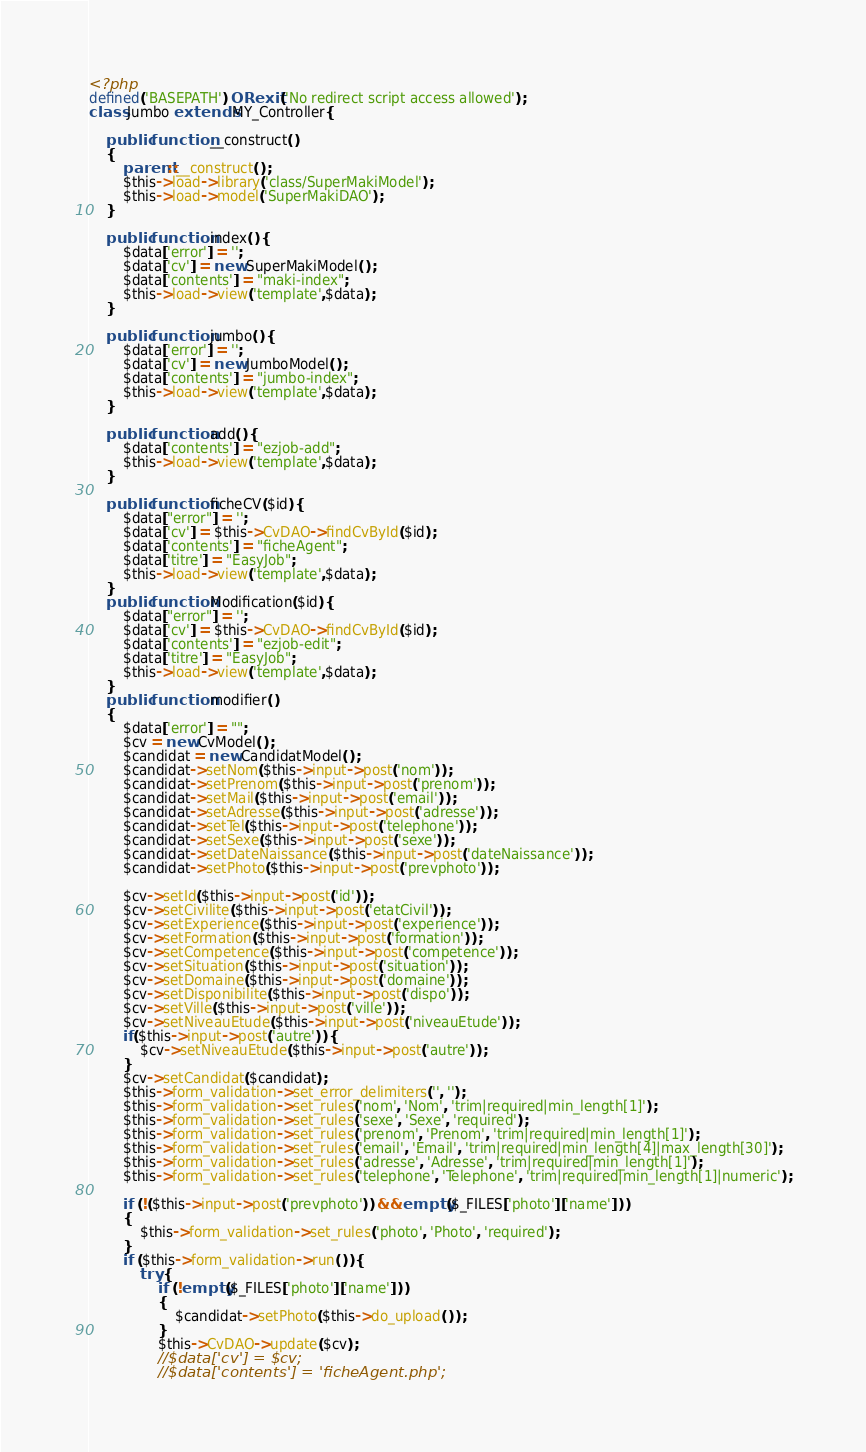<code> <loc_0><loc_0><loc_500><loc_500><_PHP_><?php
defined('BASEPATH') OR exit('No redirect script access allowed');
class Jumbo extends MY_Controller{

    public function __construct()
    {
        parent::__construct();
        $this->load->library('class/SuperMakiModel');
        $this->load->model('SuperMakiDAO');
    }

    public function index(){
        $data['error'] = '';
        $data['cv'] = new SuperMakiModel();
        $data['contents'] = "maki-index";
        $this->load->view('template',$data);
    }

    public function jumbo(){
        $data['error'] = '';
        $data['cv'] = new JumboModel();
        $data['contents'] = "jumbo-index";
        $this->load->view('template',$data);
    }

    public function add(){
        $data['contents'] = "ezjob-add";
        $this->load->view('template',$data);
    }

    public function ficheCV($id){
        $data["error"] = '';
        $data['cv'] = $this->CvDAO->findCvById($id);
        $data['contents'] = "ficheAgent";
        $data['titre'] = "EasyJob";
        $this->load->view('template',$data);
    }
    public function Modification($id){
        $data["error"] = '';
        $data['cv'] = $this->CvDAO->findCvById($id);
        $data['contents'] = "ezjob-edit";
        $data['titre'] = "EasyJob";
        $this->load->view('template',$data);
    }
    public function modifier()
    {
        $data['error'] = "";
        $cv = new CvModel();
        $candidat = new CandidatModel();
        $candidat->setNom($this->input->post('nom'));
        $candidat->setPrenom($this->input->post('prenom'));
        $candidat->setMail($this->input->post('email'));
        $candidat->setAdresse($this->input->post('adresse'));
        $candidat->setTel($this->input->post('telephone'));
        $candidat->setSexe($this->input->post('sexe'));
        $candidat->setDateNaissance($this->input->post('dateNaissance'));
        $candidat->setPhoto($this->input->post('prevphoto'));

        $cv->setId($this->input->post('id'));
        $cv->setCivilite($this->input->post('etatCivil'));
        $cv->setExperience($this->input->post('experience'));
        $cv->setFormation($this->input->post('formation'));
        $cv->setCompetence($this->input->post('competence'));
        $cv->setSituation($this->input->post('situation'));
        $cv->setDomaine($this->input->post('domaine'));
        $cv->setDisponibilite($this->input->post('dispo'));
        $cv->setVille($this->input->post('ville'));
        $cv->setNiveauEtude($this->input->post('niveauEtude'));
        if($this->input->post('autre')){
            $cv->setNiveauEtude($this->input->post('autre'));
        }
        $cv->setCandidat($candidat);
        $this->form_validation->set_error_delimiters('', '');
        $this->form_validation->set_rules('nom', 'Nom', 'trim|required|min_length[1]');
        $this->form_validation->set_rules('sexe', 'Sexe', 'required');
        $this->form_validation->set_rules('prenom', 'Prenom', 'trim|required|min_length[1]');
        $this->form_validation->set_rules('email', 'Email', 'trim|required|min_length[4]|max_length[30]');
        $this->form_validation->set_rules('adresse', 'Adresse', 'trim|required|min_length[1]');
        $this->form_validation->set_rules('telephone', 'Telephone', 'trim|required|min_length[1]|numeric');

        if (!($this->input->post('prevphoto')) && empty($_FILES['photo']['name']))
        {
            $this->form_validation->set_rules('photo', 'Photo', 'required');
        }
        if ($this->form_validation->run()) {
            try {
                if (!empty($_FILES['photo']['name']))
                {
                    $candidat->setPhoto($this->do_upload());
                }
                $this->CvDAO->update($cv);
                //$data['cv'] = $cv;
                //$data['contents'] = 'ficheAgent.php';</code> 